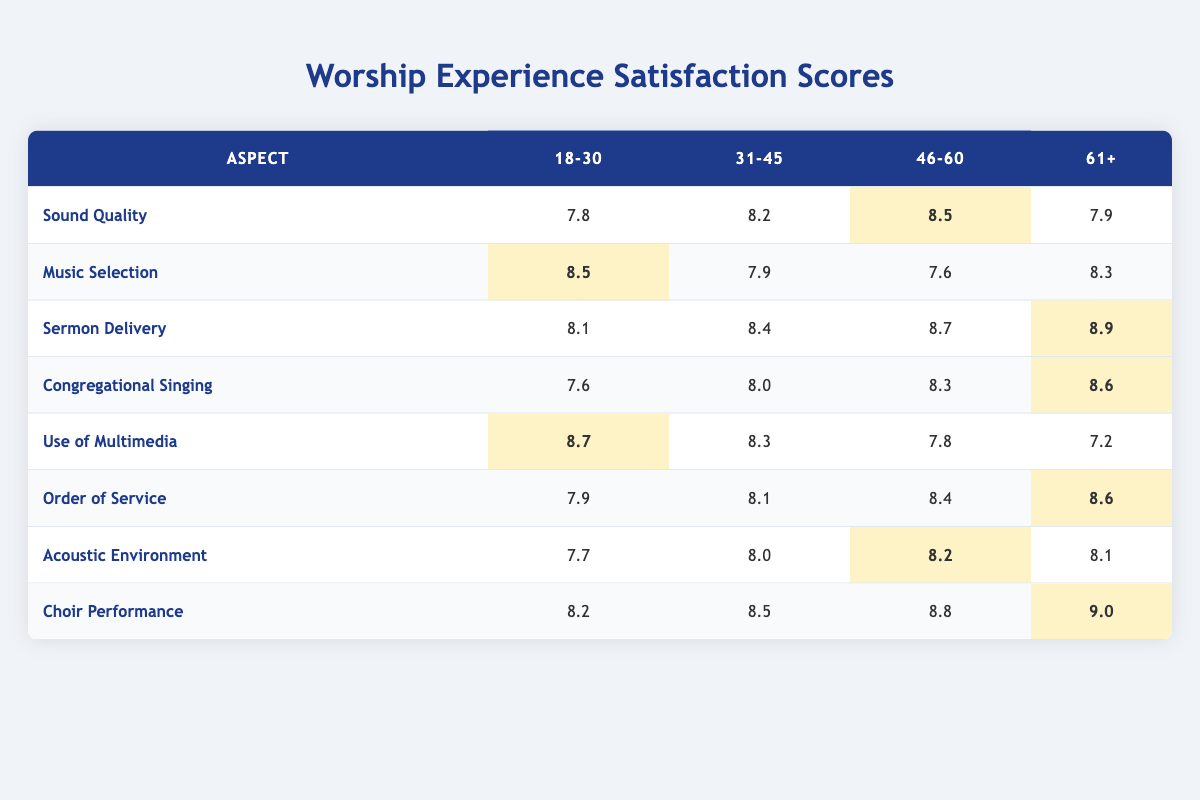What is the satisfaction score for Sound Quality in the 46-60 age group? The score for Sound Quality in the 46-60 age group can be found by looking at the corresponding row and column in the table. The score is 8.5.
Answer: 8.5 Which aspect received the lowest score in the 31-45 age group? To find the lowest score in the 31-45 age group, we compare all the scores in that column: 8.2 (Sound Quality), 7.9 (Music Selection), 8.4 (Sermon Delivery), 8.0 (Congregational Singing), 8.3 (Use of Multimedia), 8.1 (Order of Service), 8.0 (Acoustic Environment), and 8.5 (Choir Performance). The lowest score is 7.6 in Music Selection.
Answer: Music Selection Is the average score for Choir Performance across all age groups higher than 8.0? To find the average score for Choir Performance, add the scores for each age group: 8.2 + 8.5 + 8.8 + 9.0 = 34.5. Then, divide by the number of age groups (4): 34.5 / 4 = 8.625. Since 8.625 is greater than 8.0, the answer is yes.
Answer: Yes What is the difference in the satisfaction score for Sermon Delivery between the youngest and oldest age groups? The score for Sermon Delivery in the 18-30 age group is 8.1, and in the 61+ age group, it is 8.9. The difference is calculated by subtracting the younger group's score from the older group's score: 8.9 - 8.1 = 0.8.
Answer: 0.8 Did any aspect receive a score of 9.0 or higher? We check each aspect's highest scores across all age groups. The only score in the table that is 9.0 or higher is for Choir Performance, which is scored at 9.0 in the 61+ age group. Hence, the answer is yes.
Answer: Yes 